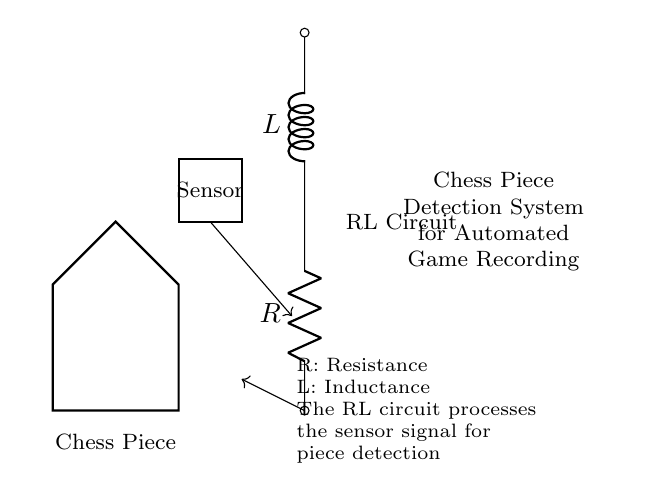What type of circuit is represented here? The circuit diagram shows a resistor in series with an inductor, which is characteristic of an RL circuit. The inclusion of both components indicates their function in managing current and voltage changes within the system.
Answer: RL circuit What does the 'R' in the circuit represent? The 'R' in the circuit denotes resistance. In the diagram, it is labeled next to the resistor component, indicating that it limits the flow of electric current in this part of the circuit.
Answer: Resistance What role does the 'L' play in the circuit? The 'L' stands for inductance, which is the property of the inductor to oppose changes in current. In this circuit, it helps smooth out the variations in electric current as the chess piece is detected.
Answer: Inductance What is the purpose of the sensor connected to the circuit? The sensor is essential for detecting the presence of chess pieces. It generates a signal that triggers the RL circuit to process this data for piece detection and game recording automation.
Answer: Detecting chess pieces How does the RL circuit process the sensor signal? The RL circuit takes the sensor signal and filters it. The resistor limits the current, while the inductor mitigates rapid changes in current, ensuring a stable output for accurate detection of the chess piece.
Answer: Filters the signal How does the RL circuit benefit the chess piece detection system? The RL circuit allows for gradual current changes, which enhances the system's sensitivity to the sensor's input, resulting in more reliable detection of chess pieces and improved automated game recording.
Answer: Enhances sensitivity 